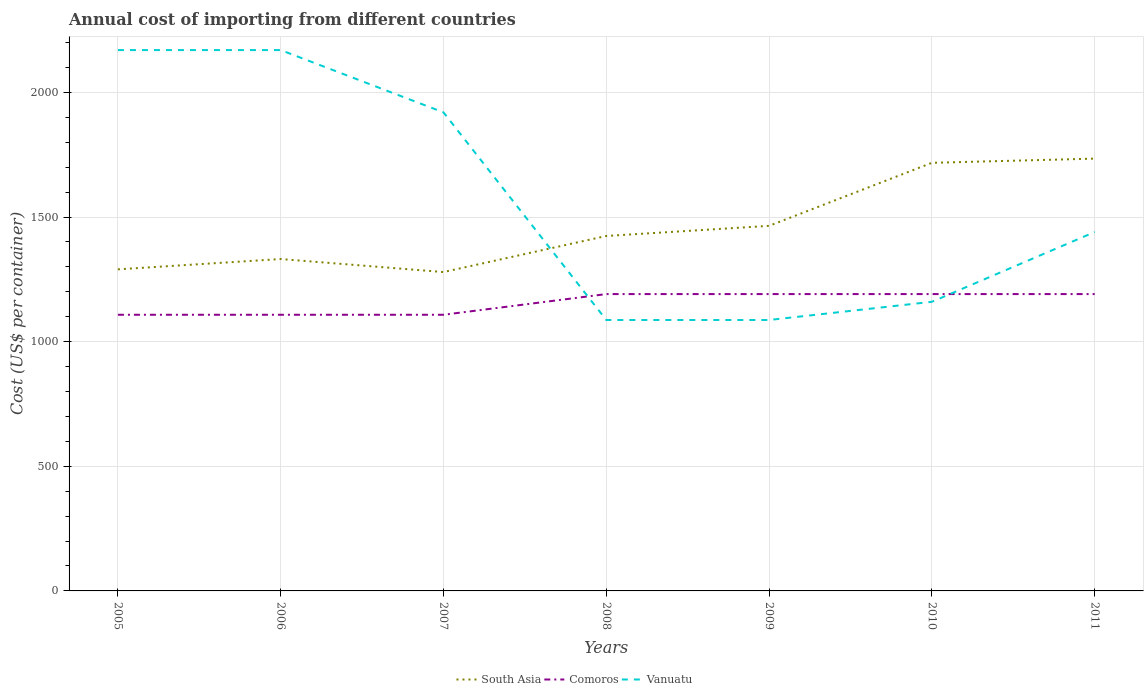How many different coloured lines are there?
Your response must be concise. 3. Across all years, what is the maximum total annual cost of importing in Comoros?
Provide a short and direct response. 1108. In which year was the total annual cost of importing in Vanuatu maximum?
Make the answer very short. 2008. What is the total total annual cost of importing in Comoros in the graph?
Your answer should be very brief. -83. What is the difference between the highest and the second highest total annual cost of importing in South Asia?
Your answer should be compact. 455.12. Is the total annual cost of importing in Comoros strictly greater than the total annual cost of importing in Vanuatu over the years?
Offer a very short reply. No. How many lines are there?
Keep it short and to the point. 3. Does the graph contain any zero values?
Your answer should be compact. No. Where does the legend appear in the graph?
Offer a very short reply. Bottom center. How many legend labels are there?
Your response must be concise. 3. What is the title of the graph?
Your answer should be very brief. Annual cost of importing from different countries. Does "Nicaragua" appear as one of the legend labels in the graph?
Keep it short and to the point. No. What is the label or title of the X-axis?
Ensure brevity in your answer.  Years. What is the label or title of the Y-axis?
Ensure brevity in your answer.  Cost (US$ per container). What is the Cost (US$ per container) in South Asia in 2005?
Offer a terse response. 1290.25. What is the Cost (US$ per container) in Comoros in 2005?
Your response must be concise. 1108. What is the Cost (US$ per container) of Vanuatu in 2005?
Make the answer very short. 2170. What is the Cost (US$ per container) of South Asia in 2006?
Your response must be concise. 1331.62. What is the Cost (US$ per container) in Comoros in 2006?
Your answer should be compact. 1108. What is the Cost (US$ per container) of Vanuatu in 2006?
Offer a terse response. 2170. What is the Cost (US$ per container) in South Asia in 2007?
Keep it short and to the point. 1279.38. What is the Cost (US$ per container) in Comoros in 2007?
Ensure brevity in your answer.  1108. What is the Cost (US$ per container) in Vanuatu in 2007?
Offer a very short reply. 1920. What is the Cost (US$ per container) of South Asia in 2008?
Provide a short and direct response. 1424.12. What is the Cost (US$ per container) of Comoros in 2008?
Your answer should be compact. 1191. What is the Cost (US$ per container) in Vanuatu in 2008?
Your answer should be very brief. 1087. What is the Cost (US$ per container) of South Asia in 2009?
Offer a very short reply. 1464.75. What is the Cost (US$ per container) in Comoros in 2009?
Your answer should be very brief. 1191. What is the Cost (US$ per container) of Vanuatu in 2009?
Provide a succinct answer. 1087. What is the Cost (US$ per container) in South Asia in 2010?
Your answer should be compact. 1717.62. What is the Cost (US$ per container) of Comoros in 2010?
Offer a terse response. 1191. What is the Cost (US$ per container) of Vanuatu in 2010?
Give a very brief answer. 1160. What is the Cost (US$ per container) in South Asia in 2011?
Offer a very short reply. 1734.5. What is the Cost (US$ per container) in Comoros in 2011?
Your answer should be very brief. 1191. What is the Cost (US$ per container) in Vanuatu in 2011?
Your answer should be very brief. 1440. Across all years, what is the maximum Cost (US$ per container) of South Asia?
Your answer should be compact. 1734.5. Across all years, what is the maximum Cost (US$ per container) of Comoros?
Offer a terse response. 1191. Across all years, what is the maximum Cost (US$ per container) of Vanuatu?
Provide a succinct answer. 2170. Across all years, what is the minimum Cost (US$ per container) in South Asia?
Offer a terse response. 1279.38. Across all years, what is the minimum Cost (US$ per container) of Comoros?
Make the answer very short. 1108. Across all years, what is the minimum Cost (US$ per container) of Vanuatu?
Provide a succinct answer. 1087. What is the total Cost (US$ per container) of South Asia in the graph?
Ensure brevity in your answer.  1.02e+04. What is the total Cost (US$ per container) in Comoros in the graph?
Offer a very short reply. 8088. What is the total Cost (US$ per container) in Vanuatu in the graph?
Provide a short and direct response. 1.10e+04. What is the difference between the Cost (US$ per container) in South Asia in 2005 and that in 2006?
Your answer should be compact. -41.38. What is the difference between the Cost (US$ per container) in South Asia in 2005 and that in 2007?
Keep it short and to the point. 10.88. What is the difference between the Cost (US$ per container) in Comoros in 2005 and that in 2007?
Your answer should be compact. 0. What is the difference between the Cost (US$ per container) of Vanuatu in 2005 and that in 2007?
Make the answer very short. 250. What is the difference between the Cost (US$ per container) in South Asia in 2005 and that in 2008?
Provide a short and direct response. -133.88. What is the difference between the Cost (US$ per container) in Comoros in 2005 and that in 2008?
Offer a terse response. -83. What is the difference between the Cost (US$ per container) of Vanuatu in 2005 and that in 2008?
Ensure brevity in your answer.  1083. What is the difference between the Cost (US$ per container) of South Asia in 2005 and that in 2009?
Offer a terse response. -174.5. What is the difference between the Cost (US$ per container) of Comoros in 2005 and that in 2009?
Keep it short and to the point. -83. What is the difference between the Cost (US$ per container) in Vanuatu in 2005 and that in 2009?
Provide a succinct answer. 1083. What is the difference between the Cost (US$ per container) in South Asia in 2005 and that in 2010?
Give a very brief answer. -427.38. What is the difference between the Cost (US$ per container) in Comoros in 2005 and that in 2010?
Your response must be concise. -83. What is the difference between the Cost (US$ per container) of Vanuatu in 2005 and that in 2010?
Keep it short and to the point. 1010. What is the difference between the Cost (US$ per container) in South Asia in 2005 and that in 2011?
Your answer should be compact. -444.25. What is the difference between the Cost (US$ per container) in Comoros in 2005 and that in 2011?
Offer a terse response. -83. What is the difference between the Cost (US$ per container) of Vanuatu in 2005 and that in 2011?
Offer a very short reply. 730. What is the difference between the Cost (US$ per container) in South Asia in 2006 and that in 2007?
Your answer should be compact. 52.25. What is the difference between the Cost (US$ per container) of Comoros in 2006 and that in 2007?
Your response must be concise. 0. What is the difference between the Cost (US$ per container) of Vanuatu in 2006 and that in 2007?
Your response must be concise. 250. What is the difference between the Cost (US$ per container) in South Asia in 2006 and that in 2008?
Give a very brief answer. -92.5. What is the difference between the Cost (US$ per container) in Comoros in 2006 and that in 2008?
Keep it short and to the point. -83. What is the difference between the Cost (US$ per container) of Vanuatu in 2006 and that in 2008?
Your answer should be very brief. 1083. What is the difference between the Cost (US$ per container) of South Asia in 2006 and that in 2009?
Your answer should be compact. -133.12. What is the difference between the Cost (US$ per container) in Comoros in 2006 and that in 2009?
Make the answer very short. -83. What is the difference between the Cost (US$ per container) in Vanuatu in 2006 and that in 2009?
Your response must be concise. 1083. What is the difference between the Cost (US$ per container) in South Asia in 2006 and that in 2010?
Offer a very short reply. -386. What is the difference between the Cost (US$ per container) of Comoros in 2006 and that in 2010?
Provide a succinct answer. -83. What is the difference between the Cost (US$ per container) in Vanuatu in 2006 and that in 2010?
Provide a short and direct response. 1010. What is the difference between the Cost (US$ per container) in South Asia in 2006 and that in 2011?
Ensure brevity in your answer.  -402.88. What is the difference between the Cost (US$ per container) in Comoros in 2006 and that in 2011?
Make the answer very short. -83. What is the difference between the Cost (US$ per container) of Vanuatu in 2006 and that in 2011?
Give a very brief answer. 730. What is the difference between the Cost (US$ per container) of South Asia in 2007 and that in 2008?
Your answer should be very brief. -144.75. What is the difference between the Cost (US$ per container) of Comoros in 2007 and that in 2008?
Offer a terse response. -83. What is the difference between the Cost (US$ per container) of Vanuatu in 2007 and that in 2008?
Provide a succinct answer. 833. What is the difference between the Cost (US$ per container) of South Asia in 2007 and that in 2009?
Provide a short and direct response. -185.38. What is the difference between the Cost (US$ per container) of Comoros in 2007 and that in 2009?
Keep it short and to the point. -83. What is the difference between the Cost (US$ per container) of Vanuatu in 2007 and that in 2009?
Make the answer very short. 833. What is the difference between the Cost (US$ per container) in South Asia in 2007 and that in 2010?
Your answer should be compact. -438.25. What is the difference between the Cost (US$ per container) of Comoros in 2007 and that in 2010?
Make the answer very short. -83. What is the difference between the Cost (US$ per container) in Vanuatu in 2007 and that in 2010?
Provide a short and direct response. 760. What is the difference between the Cost (US$ per container) of South Asia in 2007 and that in 2011?
Your answer should be compact. -455.12. What is the difference between the Cost (US$ per container) of Comoros in 2007 and that in 2011?
Offer a very short reply. -83. What is the difference between the Cost (US$ per container) in Vanuatu in 2007 and that in 2011?
Give a very brief answer. 480. What is the difference between the Cost (US$ per container) of South Asia in 2008 and that in 2009?
Make the answer very short. -40.62. What is the difference between the Cost (US$ per container) of South Asia in 2008 and that in 2010?
Provide a short and direct response. -293.5. What is the difference between the Cost (US$ per container) in Comoros in 2008 and that in 2010?
Keep it short and to the point. 0. What is the difference between the Cost (US$ per container) of Vanuatu in 2008 and that in 2010?
Make the answer very short. -73. What is the difference between the Cost (US$ per container) in South Asia in 2008 and that in 2011?
Keep it short and to the point. -310.38. What is the difference between the Cost (US$ per container) in Comoros in 2008 and that in 2011?
Make the answer very short. 0. What is the difference between the Cost (US$ per container) of Vanuatu in 2008 and that in 2011?
Provide a short and direct response. -353. What is the difference between the Cost (US$ per container) in South Asia in 2009 and that in 2010?
Offer a terse response. -252.88. What is the difference between the Cost (US$ per container) of Vanuatu in 2009 and that in 2010?
Your answer should be very brief. -73. What is the difference between the Cost (US$ per container) in South Asia in 2009 and that in 2011?
Provide a short and direct response. -269.75. What is the difference between the Cost (US$ per container) of Vanuatu in 2009 and that in 2011?
Offer a terse response. -353. What is the difference between the Cost (US$ per container) in South Asia in 2010 and that in 2011?
Offer a terse response. -16.88. What is the difference between the Cost (US$ per container) in Vanuatu in 2010 and that in 2011?
Your response must be concise. -280. What is the difference between the Cost (US$ per container) in South Asia in 2005 and the Cost (US$ per container) in Comoros in 2006?
Your answer should be very brief. 182.25. What is the difference between the Cost (US$ per container) in South Asia in 2005 and the Cost (US$ per container) in Vanuatu in 2006?
Provide a short and direct response. -879.75. What is the difference between the Cost (US$ per container) of Comoros in 2005 and the Cost (US$ per container) of Vanuatu in 2006?
Provide a succinct answer. -1062. What is the difference between the Cost (US$ per container) in South Asia in 2005 and the Cost (US$ per container) in Comoros in 2007?
Give a very brief answer. 182.25. What is the difference between the Cost (US$ per container) of South Asia in 2005 and the Cost (US$ per container) of Vanuatu in 2007?
Offer a very short reply. -629.75. What is the difference between the Cost (US$ per container) in Comoros in 2005 and the Cost (US$ per container) in Vanuatu in 2007?
Your response must be concise. -812. What is the difference between the Cost (US$ per container) of South Asia in 2005 and the Cost (US$ per container) of Comoros in 2008?
Keep it short and to the point. 99.25. What is the difference between the Cost (US$ per container) in South Asia in 2005 and the Cost (US$ per container) in Vanuatu in 2008?
Your answer should be compact. 203.25. What is the difference between the Cost (US$ per container) of South Asia in 2005 and the Cost (US$ per container) of Comoros in 2009?
Offer a terse response. 99.25. What is the difference between the Cost (US$ per container) of South Asia in 2005 and the Cost (US$ per container) of Vanuatu in 2009?
Provide a succinct answer. 203.25. What is the difference between the Cost (US$ per container) in Comoros in 2005 and the Cost (US$ per container) in Vanuatu in 2009?
Offer a terse response. 21. What is the difference between the Cost (US$ per container) of South Asia in 2005 and the Cost (US$ per container) of Comoros in 2010?
Provide a succinct answer. 99.25. What is the difference between the Cost (US$ per container) of South Asia in 2005 and the Cost (US$ per container) of Vanuatu in 2010?
Your response must be concise. 130.25. What is the difference between the Cost (US$ per container) of Comoros in 2005 and the Cost (US$ per container) of Vanuatu in 2010?
Provide a short and direct response. -52. What is the difference between the Cost (US$ per container) in South Asia in 2005 and the Cost (US$ per container) in Comoros in 2011?
Your response must be concise. 99.25. What is the difference between the Cost (US$ per container) in South Asia in 2005 and the Cost (US$ per container) in Vanuatu in 2011?
Offer a very short reply. -149.75. What is the difference between the Cost (US$ per container) in Comoros in 2005 and the Cost (US$ per container) in Vanuatu in 2011?
Provide a succinct answer. -332. What is the difference between the Cost (US$ per container) of South Asia in 2006 and the Cost (US$ per container) of Comoros in 2007?
Make the answer very short. 223.62. What is the difference between the Cost (US$ per container) of South Asia in 2006 and the Cost (US$ per container) of Vanuatu in 2007?
Offer a terse response. -588.38. What is the difference between the Cost (US$ per container) of Comoros in 2006 and the Cost (US$ per container) of Vanuatu in 2007?
Keep it short and to the point. -812. What is the difference between the Cost (US$ per container) in South Asia in 2006 and the Cost (US$ per container) in Comoros in 2008?
Offer a very short reply. 140.62. What is the difference between the Cost (US$ per container) of South Asia in 2006 and the Cost (US$ per container) of Vanuatu in 2008?
Offer a very short reply. 244.62. What is the difference between the Cost (US$ per container) of South Asia in 2006 and the Cost (US$ per container) of Comoros in 2009?
Provide a short and direct response. 140.62. What is the difference between the Cost (US$ per container) in South Asia in 2006 and the Cost (US$ per container) in Vanuatu in 2009?
Ensure brevity in your answer.  244.62. What is the difference between the Cost (US$ per container) of South Asia in 2006 and the Cost (US$ per container) of Comoros in 2010?
Make the answer very short. 140.62. What is the difference between the Cost (US$ per container) of South Asia in 2006 and the Cost (US$ per container) of Vanuatu in 2010?
Keep it short and to the point. 171.62. What is the difference between the Cost (US$ per container) in Comoros in 2006 and the Cost (US$ per container) in Vanuatu in 2010?
Keep it short and to the point. -52. What is the difference between the Cost (US$ per container) of South Asia in 2006 and the Cost (US$ per container) of Comoros in 2011?
Make the answer very short. 140.62. What is the difference between the Cost (US$ per container) in South Asia in 2006 and the Cost (US$ per container) in Vanuatu in 2011?
Make the answer very short. -108.38. What is the difference between the Cost (US$ per container) of Comoros in 2006 and the Cost (US$ per container) of Vanuatu in 2011?
Offer a very short reply. -332. What is the difference between the Cost (US$ per container) in South Asia in 2007 and the Cost (US$ per container) in Comoros in 2008?
Give a very brief answer. 88.38. What is the difference between the Cost (US$ per container) in South Asia in 2007 and the Cost (US$ per container) in Vanuatu in 2008?
Keep it short and to the point. 192.38. What is the difference between the Cost (US$ per container) in Comoros in 2007 and the Cost (US$ per container) in Vanuatu in 2008?
Keep it short and to the point. 21. What is the difference between the Cost (US$ per container) of South Asia in 2007 and the Cost (US$ per container) of Comoros in 2009?
Provide a short and direct response. 88.38. What is the difference between the Cost (US$ per container) of South Asia in 2007 and the Cost (US$ per container) of Vanuatu in 2009?
Offer a terse response. 192.38. What is the difference between the Cost (US$ per container) in Comoros in 2007 and the Cost (US$ per container) in Vanuatu in 2009?
Provide a succinct answer. 21. What is the difference between the Cost (US$ per container) of South Asia in 2007 and the Cost (US$ per container) of Comoros in 2010?
Your response must be concise. 88.38. What is the difference between the Cost (US$ per container) of South Asia in 2007 and the Cost (US$ per container) of Vanuatu in 2010?
Make the answer very short. 119.38. What is the difference between the Cost (US$ per container) in Comoros in 2007 and the Cost (US$ per container) in Vanuatu in 2010?
Make the answer very short. -52. What is the difference between the Cost (US$ per container) in South Asia in 2007 and the Cost (US$ per container) in Comoros in 2011?
Your response must be concise. 88.38. What is the difference between the Cost (US$ per container) in South Asia in 2007 and the Cost (US$ per container) in Vanuatu in 2011?
Give a very brief answer. -160.62. What is the difference between the Cost (US$ per container) of Comoros in 2007 and the Cost (US$ per container) of Vanuatu in 2011?
Provide a succinct answer. -332. What is the difference between the Cost (US$ per container) of South Asia in 2008 and the Cost (US$ per container) of Comoros in 2009?
Provide a short and direct response. 233.12. What is the difference between the Cost (US$ per container) of South Asia in 2008 and the Cost (US$ per container) of Vanuatu in 2009?
Make the answer very short. 337.12. What is the difference between the Cost (US$ per container) of Comoros in 2008 and the Cost (US$ per container) of Vanuatu in 2009?
Offer a terse response. 104. What is the difference between the Cost (US$ per container) in South Asia in 2008 and the Cost (US$ per container) in Comoros in 2010?
Keep it short and to the point. 233.12. What is the difference between the Cost (US$ per container) in South Asia in 2008 and the Cost (US$ per container) in Vanuatu in 2010?
Ensure brevity in your answer.  264.12. What is the difference between the Cost (US$ per container) of South Asia in 2008 and the Cost (US$ per container) of Comoros in 2011?
Your answer should be very brief. 233.12. What is the difference between the Cost (US$ per container) of South Asia in 2008 and the Cost (US$ per container) of Vanuatu in 2011?
Ensure brevity in your answer.  -15.88. What is the difference between the Cost (US$ per container) of Comoros in 2008 and the Cost (US$ per container) of Vanuatu in 2011?
Provide a succinct answer. -249. What is the difference between the Cost (US$ per container) of South Asia in 2009 and the Cost (US$ per container) of Comoros in 2010?
Provide a succinct answer. 273.75. What is the difference between the Cost (US$ per container) in South Asia in 2009 and the Cost (US$ per container) in Vanuatu in 2010?
Your answer should be compact. 304.75. What is the difference between the Cost (US$ per container) in Comoros in 2009 and the Cost (US$ per container) in Vanuatu in 2010?
Provide a short and direct response. 31. What is the difference between the Cost (US$ per container) of South Asia in 2009 and the Cost (US$ per container) of Comoros in 2011?
Make the answer very short. 273.75. What is the difference between the Cost (US$ per container) of South Asia in 2009 and the Cost (US$ per container) of Vanuatu in 2011?
Your answer should be compact. 24.75. What is the difference between the Cost (US$ per container) of Comoros in 2009 and the Cost (US$ per container) of Vanuatu in 2011?
Make the answer very short. -249. What is the difference between the Cost (US$ per container) of South Asia in 2010 and the Cost (US$ per container) of Comoros in 2011?
Your answer should be very brief. 526.62. What is the difference between the Cost (US$ per container) in South Asia in 2010 and the Cost (US$ per container) in Vanuatu in 2011?
Keep it short and to the point. 277.62. What is the difference between the Cost (US$ per container) in Comoros in 2010 and the Cost (US$ per container) in Vanuatu in 2011?
Your answer should be compact. -249. What is the average Cost (US$ per container) in South Asia per year?
Give a very brief answer. 1463.18. What is the average Cost (US$ per container) of Comoros per year?
Your response must be concise. 1155.43. What is the average Cost (US$ per container) in Vanuatu per year?
Offer a terse response. 1576.29. In the year 2005, what is the difference between the Cost (US$ per container) of South Asia and Cost (US$ per container) of Comoros?
Your answer should be very brief. 182.25. In the year 2005, what is the difference between the Cost (US$ per container) in South Asia and Cost (US$ per container) in Vanuatu?
Make the answer very short. -879.75. In the year 2005, what is the difference between the Cost (US$ per container) of Comoros and Cost (US$ per container) of Vanuatu?
Provide a short and direct response. -1062. In the year 2006, what is the difference between the Cost (US$ per container) in South Asia and Cost (US$ per container) in Comoros?
Provide a succinct answer. 223.62. In the year 2006, what is the difference between the Cost (US$ per container) of South Asia and Cost (US$ per container) of Vanuatu?
Offer a very short reply. -838.38. In the year 2006, what is the difference between the Cost (US$ per container) in Comoros and Cost (US$ per container) in Vanuatu?
Offer a very short reply. -1062. In the year 2007, what is the difference between the Cost (US$ per container) in South Asia and Cost (US$ per container) in Comoros?
Your answer should be compact. 171.38. In the year 2007, what is the difference between the Cost (US$ per container) of South Asia and Cost (US$ per container) of Vanuatu?
Ensure brevity in your answer.  -640.62. In the year 2007, what is the difference between the Cost (US$ per container) of Comoros and Cost (US$ per container) of Vanuatu?
Your answer should be very brief. -812. In the year 2008, what is the difference between the Cost (US$ per container) in South Asia and Cost (US$ per container) in Comoros?
Your response must be concise. 233.12. In the year 2008, what is the difference between the Cost (US$ per container) of South Asia and Cost (US$ per container) of Vanuatu?
Provide a short and direct response. 337.12. In the year 2008, what is the difference between the Cost (US$ per container) in Comoros and Cost (US$ per container) in Vanuatu?
Your answer should be very brief. 104. In the year 2009, what is the difference between the Cost (US$ per container) in South Asia and Cost (US$ per container) in Comoros?
Ensure brevity in your answer.  273.75. In the year 2009, what is the difference between the Cost (US$ per container) in South Asia and Cost (US$ per container) in Vanuatu?
Your response must be concise. 377.75. In the year 2009, what is the difference between the Cost (US$ per container) in Comoros and Cost (US$ per container) in Vanuatu?
Make the answer very short. 104. In the year 2010, what is the difference between the Cost (US$ per container) in South Asia and Cost (US$ per container) in Comoros?
Offer a terse response. 526.62. In the year 2010, what is the difference between the Cost (US$ per container) in South Asia and Cost (US$ per container) in Vanuatu?
Offer a terse response. 557.62. In the year 2010, what is the difference between the Cost (US$ per container) in Comoros and Cost (US$ per container) in Vanuatu?
Give a very brief answer. 31. In the year 2011, what is the difference between the Cost (US$ per container) in South Asia and Cost (US$ per container) in Comoros?
Your answer should be very brief. 543.5. In the year 2011, what is the difference between the Cost (US$ per container) in South Asia and Cost (US$ per container) in Vanuatu?
Offer a very short reply. 294.5. In the year 2011, what is the difference between the Cost (US$ per container) in Comoros and Cost (US$ per container) in Vanuatu?
Give a very brief answer. -249. What is the ratio of the Cost (US$ per container) of South Asia in 2005 to that in 2006?
Offer a very short reply. 0.97. What is the ratio of the Cost (US$ per container) in Comoros in 2005 to that in 2006?
Offer a very short reply. 1. What is the ratio of the Cost (US$ per container) of Vanuatu in 2005 to that in 2006?
Provide a succinct answer. 1. What is the ratio of the Cost (US$ per container) of South Asia in 2005 to that in 2007?
Your answer should be compact. 1.01. What is the ratio of the Cost (US$ per container) in Vanuatu in 2005 to that in 2007?
Provide a succinct answer. 1.13. What is the ratio of the Cost (US$ per container) of South Asia in 2005 to that in 2008?
Provide a short and direct response. 0.91. What is the ratio of the Cost (US$ per container) in Comoros in 2005 to that in 2008?
Provide a short and direct response. 0.93. What is the ratio of the Cost (US$ per container) in Vanuatu in 2005 to that in 2008?
Your answer should be very brief. 2. What is the ratio of the Cost (US$ per container) of South Asia in 2005 to that in 2009?
Your response must be concise. 0.88. What is the ratio of the Cost (US$ per container) of Comoros in 2005 to that in 2009?
Your answer should be very brief. 0.93. What is the ratio of the Cost (US$ per container) of Vanuatu in 2005 to that in 2009?
Offer a terse response. 2. What is the ratio of the Cost (US$ per container) in South Asia in 2005 to that in 2010?
Offer a terse response. 0.75. What is the ratio of the Cost (US$ per container) in Comoros in 2005 to that in 2010?
Make the answer very short. 0.93. What is the ratio of the Cost (US$ per container) of Vanuatu in 2005 to that in 2010?
Give a very brief answer. 1.87. What is the ratio of the Cost (US$ per container) in South Asia in 2005 to that in 2011?
Keep it short and to the point. 0.74. What is the ratio of the Cost (US$ per container) of Comoros in 2005 to that in 2011?
Provide a succinct answer. 0.93. What is the ratio of the Cost (US$ per container) of Vanuatu in 2005 to that in 2011?
Keep it short and to the point. 1.51. What is the ratio of the Cost (US$ per container) in South Asia in 2006 to that in 2007?
Your answer should be compact. 1.04. What is the ratio of the Cost (US$ per container) of Vanuatu in 2006 to that in 2007?
Make the answer very short. 1.13. What is the ratio of the Cost (US$ per container) of South Asia in 2006 to that in 2008?
Your response must be concise. 0.94. What is the ratio of the Cost (US$ per container) in Comoros in 2006 to that in 2008?
Offer a very short reply. 0.93. What is the ratio of the Cost (US$ per container) in Vanuatu in 2006 to that in 2008?
Your answer should be very brief. 2. What is the ratio of the Cost (US$ per container) in Comoros in 2006 to that in 2009?
Make the answer very short. 0.93. What is the ratio of the Cost (US$ per container) in Vanuatu in 2006 to that in 2009?
Ensure brevity in your answer.  2. What is the ratio of the Cost (US$ per container) in South Asia in 2006 to that in 2010?
Your answer should be very brief. 0.78. What is the ratio of the Cost (US$ per container) of Comoros in 2006 to that in 2010?
Offer a very short reply. 0.93. What is the ratio of the Cost (US$ per container) in Vanuatu in 2006 to that in 2010?
Offer a terse response. 1.87. What is the ratio of the Cost (US$ per container) of South Asia in 2006 to that in 2011?
Ensure brevity in your answer.  0.77. What is the ratio of the Cost (US$ per container) of Comoros in 2006 to that in 2011?
Your response must be concise. 0.93. What is the ratio of the Cost (US$ per container) of Vanuatu in 2006 to that in 2011?
Offer a terse response. 1.51. What is the ratio of the Cost (US$ per container) of South Asia in 2007 to that in 2008?
Give a very brief answer. 0.9. What is the ratio of the Cost (US$ per container) of Comoros in 2007 to that in 2008?
Your answer should be compact. 0.93. What is the ratio of the Cost (US$ per container) in Vanuatu in 2007 to that in 2008?
Give a very brief answer. 1.77. What is the ratio of the Cost (US$ per container) in South Asia in 2007 to that in 2009?
Offer a very short reply. 0.87. What is the ratio of the Cost (US$ per container) of Comoros in 2007 to that in 2009?
Offer a terse response. 0.93. What is the ratio of the Cost (US$ per container) of Vanuatu in 2007 to that in 2009?
Your answer should be very brief. 1.77. What is the ratio of the Cost (US$ per container) in South Asia in 2007 to that in 2010?
Ensure brevity in your answer.  0.74. What is the ratio of the Cost (US$ per container) of Comoros in 2007 to that in 2010?
Keep it short and to the point. 0.93. What is the ratio of the Cost (US$ per container) of Vanuatu in 2007 to that in 2010?
Provide a short and direct response. 1.66. What is the ratio of the Cost (US$ per container) of South Asia in 2007 to that in 2011?
Provide a succinct answer. 0.74. What is the ratio of the Cost (US$ per container) in Comoros in 2007 to that in 2011?
Keep it short and to the point. 0.93. What is the ratio of the Cost (US$ per container) in Vanuatu in 2007 to that in 2011?
Keep it short and to the point. 1.33. What is the ratio of the Cost (US$ per container) of South Asia in 2008 to that in 2009?
Ensure brevity in your answer.  0.97. What is the ratio of the Cost (US$ per container) in Vanuatu in 2008 to that in 2009?
Make the answer very short. 1. What is the ratio of the Cost (US$ per container) in South Asia in 2008 to that in 2010?
Your answer should be very brief. 0.83. What is the ratio of the Cost (US$ per container) in Vanuatu in 2008 to that in 2010?
Make the answer very short. 0.94. What is the ratio of the Cost (US$ per container) of South Asia in 2008 to that in 2011?
Offer a very short reply. 0.82. What is the ratio of the Cost (US$ per container) of Vanuatu in 2008 to that in 2011?
Offer a terse response. 0.75. What is the ratio of the Cost (US$ per container) in South Asia in 2009 to that in 2010?
Give a very brief answer. 0.85. What is the ratio of the Cost (US$ per container) in Vanuatu in 2009 to that in 2010?
Your response must be concise. 0.94. What is the ratio of the Cost (US$ per container) in South Asia in 2009 to that in 2011?
Give a very brief answer. 0.84. What is the ratio of the Cost (US$ per container) of Vanuatu in 2009 to that in 2011?
Provide a succinct answer. 0.75. What is the ratio of the Cost (US$ per container) in South Asia in 2010 to that in 2011?
Keep it short and to the point. 0.99. What is the ratio of the Cost (US$ per container) in Comoros in 2010 to that in 2011?
Your response must be concise. 1. What is the ratio of the Cost (US$ per container) in Vanuatu in 2010 to that in 2011?
Your response must be concise. 0.81. What is the difference between the highest and the second highest Cost (US$ per container) in South Asia?
Provide a short and direct response. 16.88. What is the difference between the highest and the lowest Cost (US$ per container) of South Asia?
Offer a terse response. 455.12. What is the difference between the highest and the lowest Cost (US$ per container) of Vanuatu?
Your answer should be compact. 1083. 